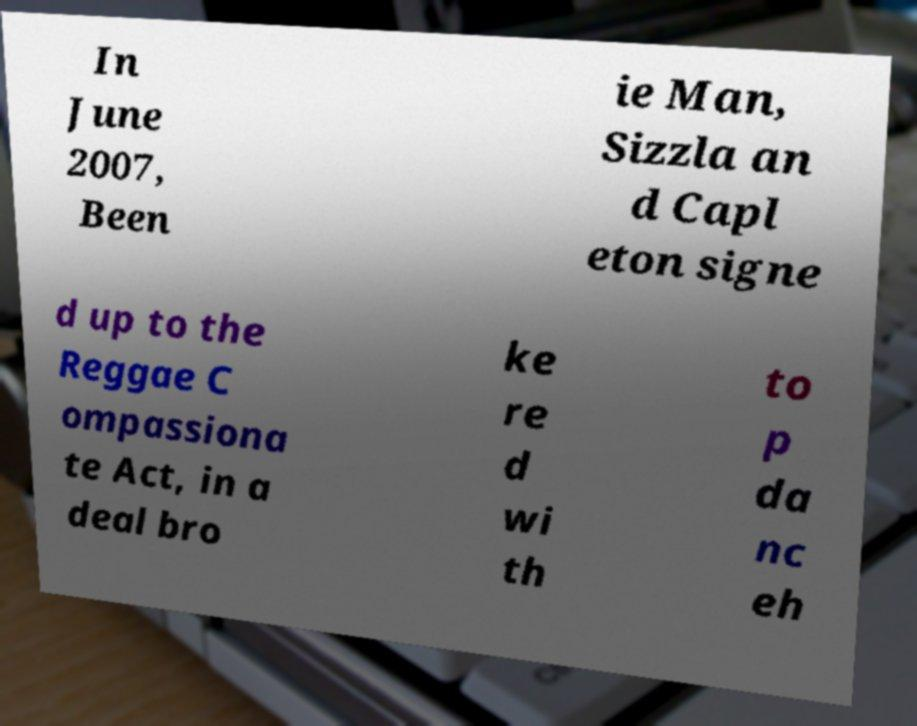Please identify and transcribe the text found in this image. In June 2007, Been ie Man, Sizzla an d Capl eton signe d up to the Reggae C ompassiona te Act, in a deal bro ke re d wi th to p da nc eh 